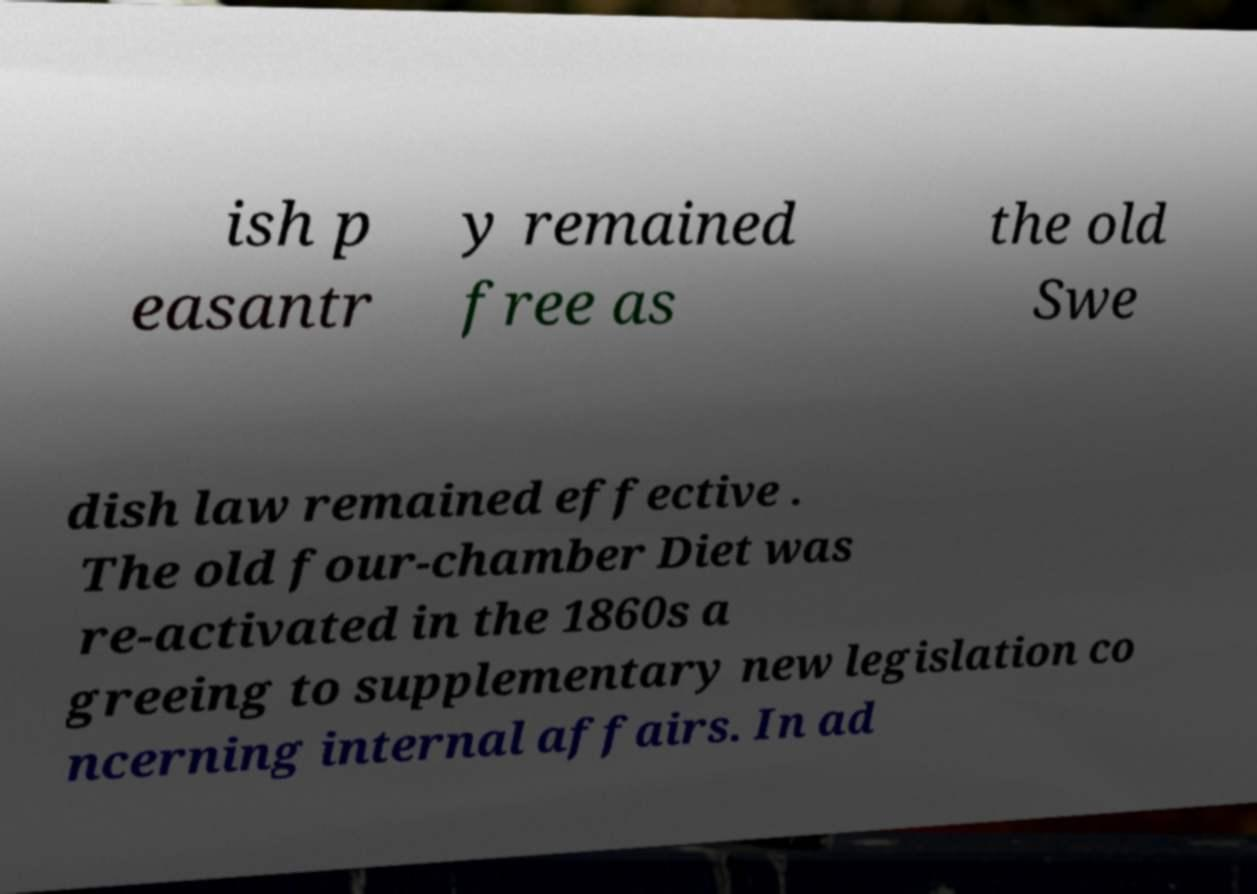Please read and relay the text visible in this image. What does it say? ish p easantr y remained free as the old Swe dish law remained effective . The old four-chamber Diet was re-activated in the 1860s a greeing to supplementary new legislation co ncerning internal affairs. In ad 